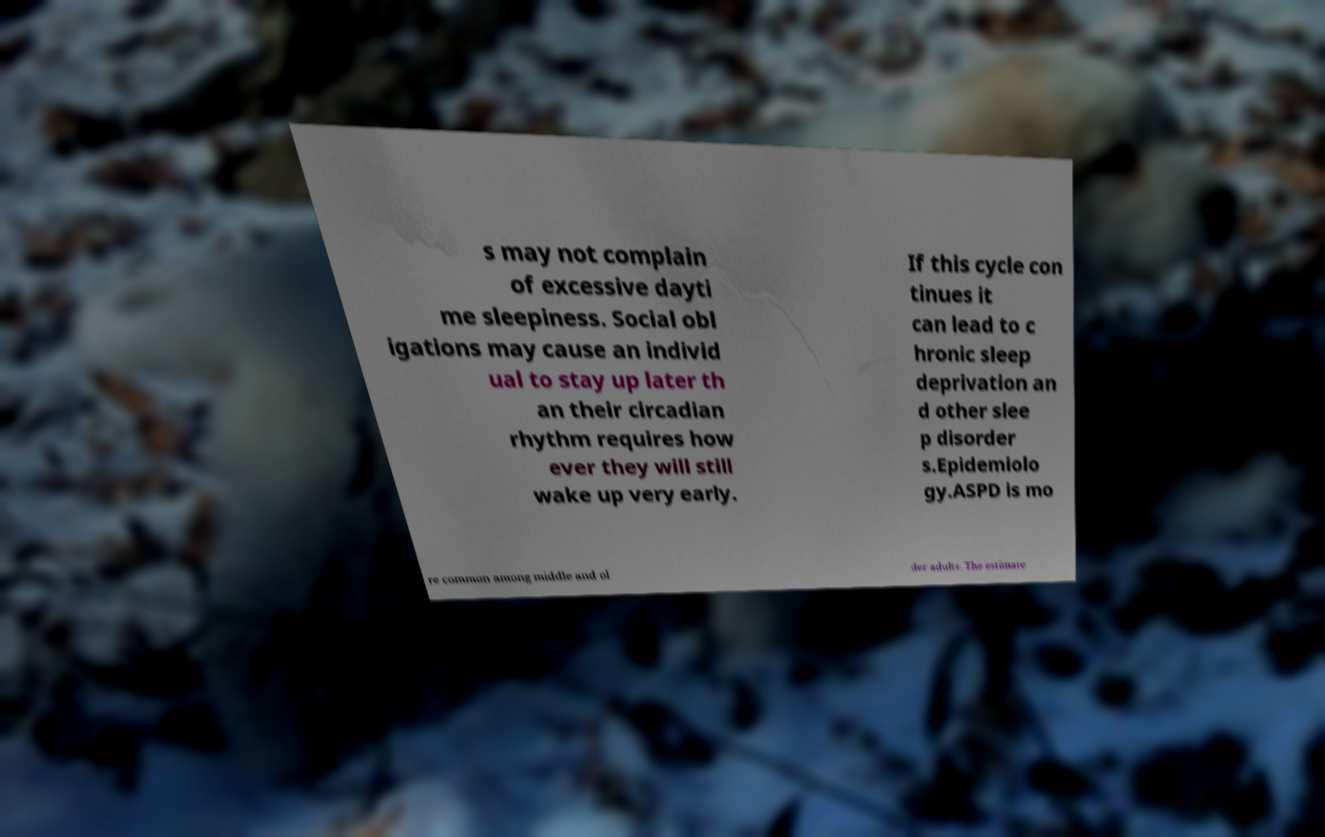Could you assist in decoding the text presented in this image and type it out clearly? s may not complain of excessive dayti me sleepiness. Social obl igations may cause an individ ual to stay up later th an their circadian rhythm requires how ever they will still wake up very early. If this cycle con tinues it can lead to c hronic sleep deprivation an d other slee p disorder s.Epidemiolo gy.ASPD is mo re common among middle and ol der adults. The estimate 